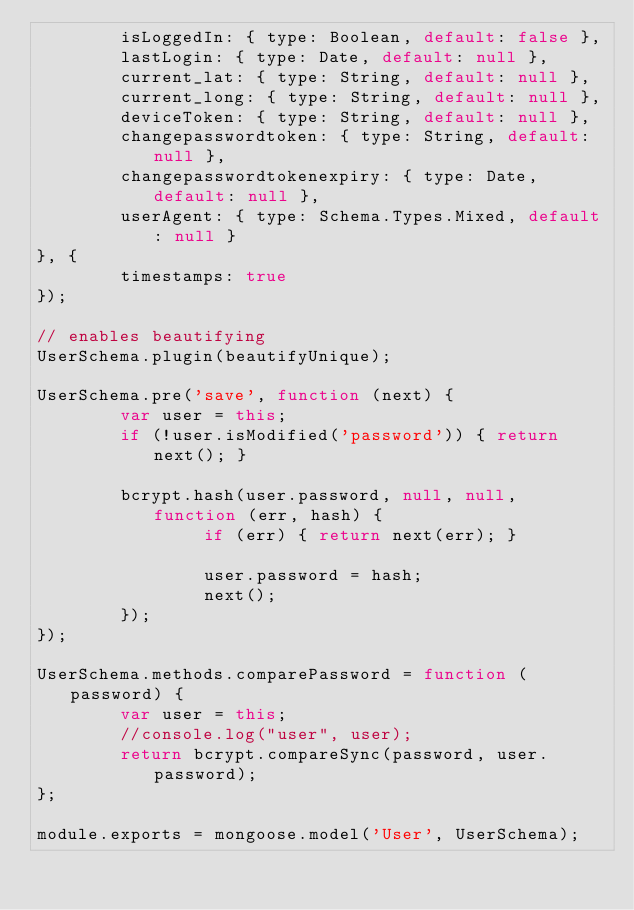<code> <loc_0><loc_0><loc_500><loc_500><_JavaScript_>        isLoggedIn: { type: Boolean, default: false },
        lastLogin: { type: Date, default: null },
        current_lat: { type: String, default: null },
        current_long: { type: String, default: null },
        deviceToken: { type: String, default: null },
        changepasswordtoken: { type: String, default: null },
        changepasswordtokenexpiry: { type: Date, default: null },
        userAgent: { type: Schema.Types.Mixed, default: null }
}, {
        timestamps: true
});

// enables beautifying 
UserSchema.plugin(beautifyUnique);

UserSchema.pre('save', function (next) {
        var user = this;
        if (!user.isModified('password')) { return next(); }

        bcrypt.hash(user.password, null, null, function (err, hash) {
                if (err) { return next(err); }

                user.password = hash;
                next();
        });
});

UserSchema.methods.comparePassword = function (password) {
        var user = this;
        //console.log("user", user);
        return bcrypt.compareSync(password, user.password);
};

module.exports = mongoose.model('User', UserSchema);</code> 